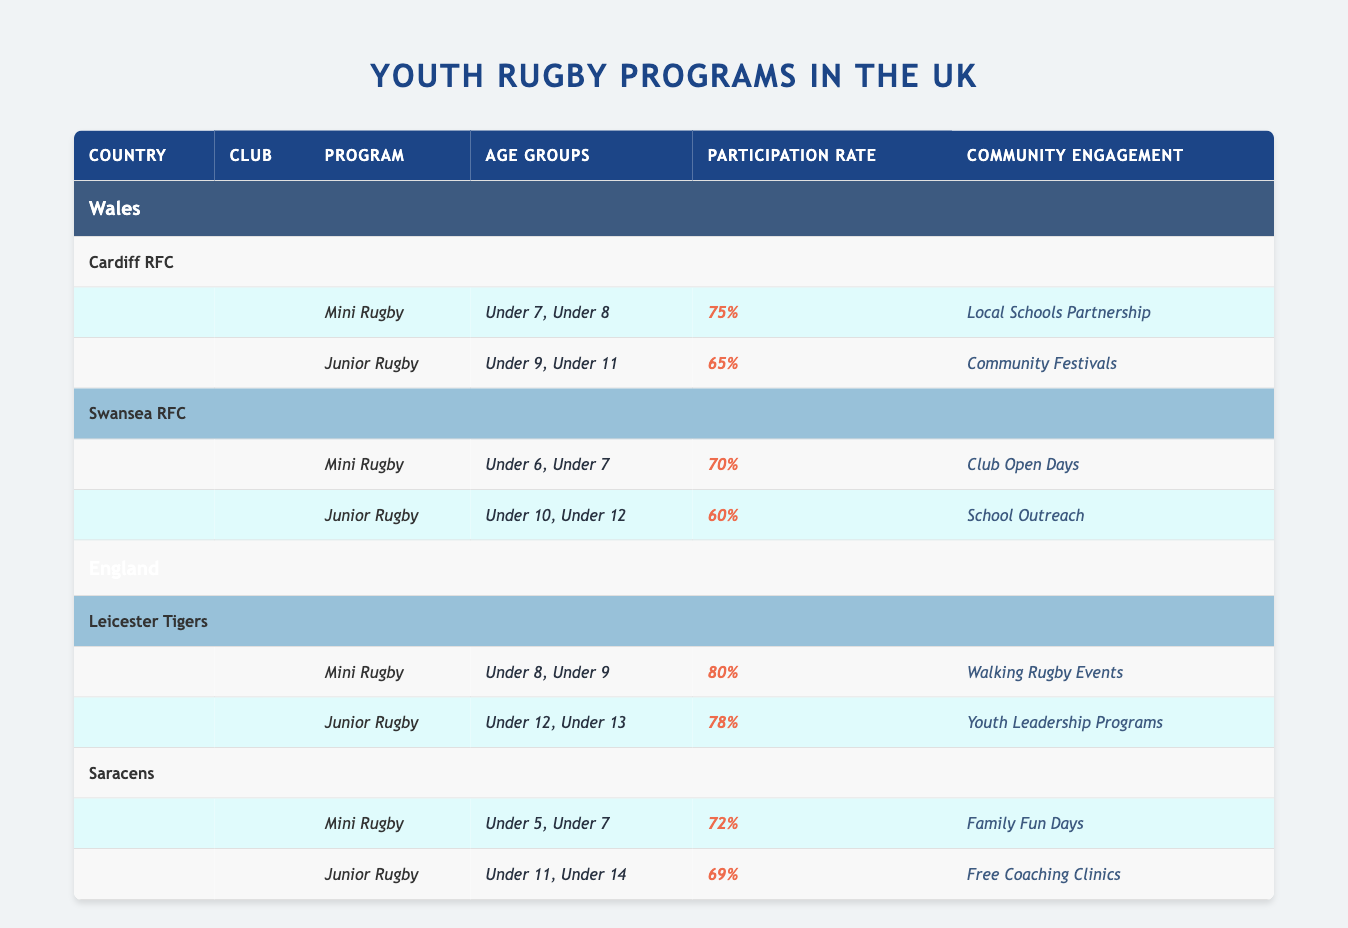What is the participation rate for Mini Rugby at Cardiff RFC? Looking at the table, we find Cardiff RFC listed under Wales with a program for Mini Rugby. The Participation Rate for Mini Rugby is stated as 75%.
Answer: 75% Which club has the highest participation rate for Junior Rugby? From the table, we compare the Junior Rugby participation rates: Cardiff RFC has 65%, Swansea RFC has 60%, Leicester Tigers has 78%, and Saracens has 69%. The highest is Leicester Tigers at 78%.
Answer: Leicester Tigers Is the community engagement program for Swansea RFC's Junior Rugby a School Outreach? Checking the table for Swansea RFC, its Junior Rugby program lists the Community Engagement as School Outreach. Therefore, the statement is true.
Answer: Yes What is the average participation rate for Mini Rugby programs across all clubs? The participation rates for Mini Rugby are 75% (Cardiff RFC), 70% (Swansea RFC), 80% (Leicester Tigers), and 72% (Saracens). We sum these: 75 + 70 + 80 + 72 = 297. There are 4 clubs, so the average is 297 / 4 = 74.25%.
Answer: 74.25% How many unique age groups are represented in the Mini Rugby programs? Listing the age groups for Mini Rugby programs: Cardiff RFC has Under 7 and Under 8; Swansea RFC has Under 6 and Under 7; Leicester Tigers has Under 8 and Under 9; Saracens has Under 5 and Under 7. The unique age groups are Under 5, Under 6, Under 7, Under 8, and Under 9, which totals 5 unique groups.
Answer: 5 Does Leicester Tigers engage the community through Youth Leadership Programs? The table specifies that Leicester Tigers' community engagement for Junior Rugby programs is Youth Leadership Programs. Hence, the statement is true.
Answer: Yes What is the difference in participation rates for Junior Rugby between the club with the highest and lowest rates? The participation rates for Junior Rugby are 65% (Cardiff RFC), 60% (Swansea RFC), 78% (Leicester Tigers), and 69% (Saracens). The highest is 78% and the lowest is 60%. The difference is 78% - 60% = 18%.
Answer: 18% Which club has a community engagement program focused on Family Fun Days? The table indicates that Saracens has a community engagement program titled Family Fun Days for their Mini Rugby.
Answer: Saracens How many age groups are involved in the Junior Rugby program at Leicester Tigers? Looking at Leicester Tigers' Junior Rugby program, the age groups listed are Under 12 and Under 13, totaling 2 age groups.
Answer: 2 